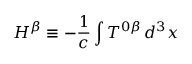Convert formula to latex. <formula><loc_0><loc_0><loc_500><loc_500>H ^ { \beta } \equiv - \frac { 1 } { c } \int T ^ { 0 \beta } \, d ^ { 3 } x</formula> 